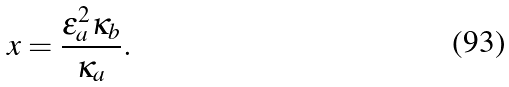<formula> <loc_0><loc_0><loc_500><loc_500>x = \frac { \epsilon ^ { 2 } _ { a } \kappa _ { b } } { \kappa _ { a } } .</formula> 